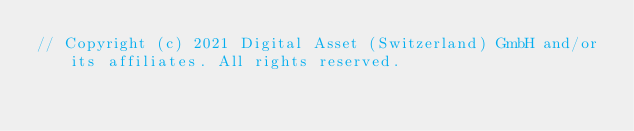Convert code to text. <code><loc_0><loc_0><loc_500><loc_500><_Scala_>// Copyright (c) 2021 Digital Asset (Switzerland) GmbH and/or its affiliates. All rights reserved.</code> 